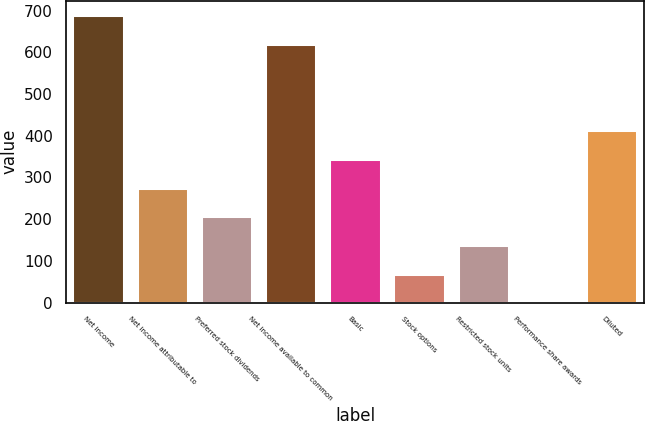<chart> <loc_0><loc_0><loc_500><loc_500><bar_chart><fcel>Net income<fcel>Net income attributable to<fcel>Preferred stock dividends<fcel>Net income available to common<fcel>Basic<fcel>Stock options<fcel>Restricted stock units<fcel>Performance share awards<fcel>Diluted<nl><fcel>688.9<fcel>275.8<fcel>206.95<fcel>619.7<fcel>344.65<fcel>69.25<fcel>138.1<fcel>0.4<fcel>413.5<nl></chart> 